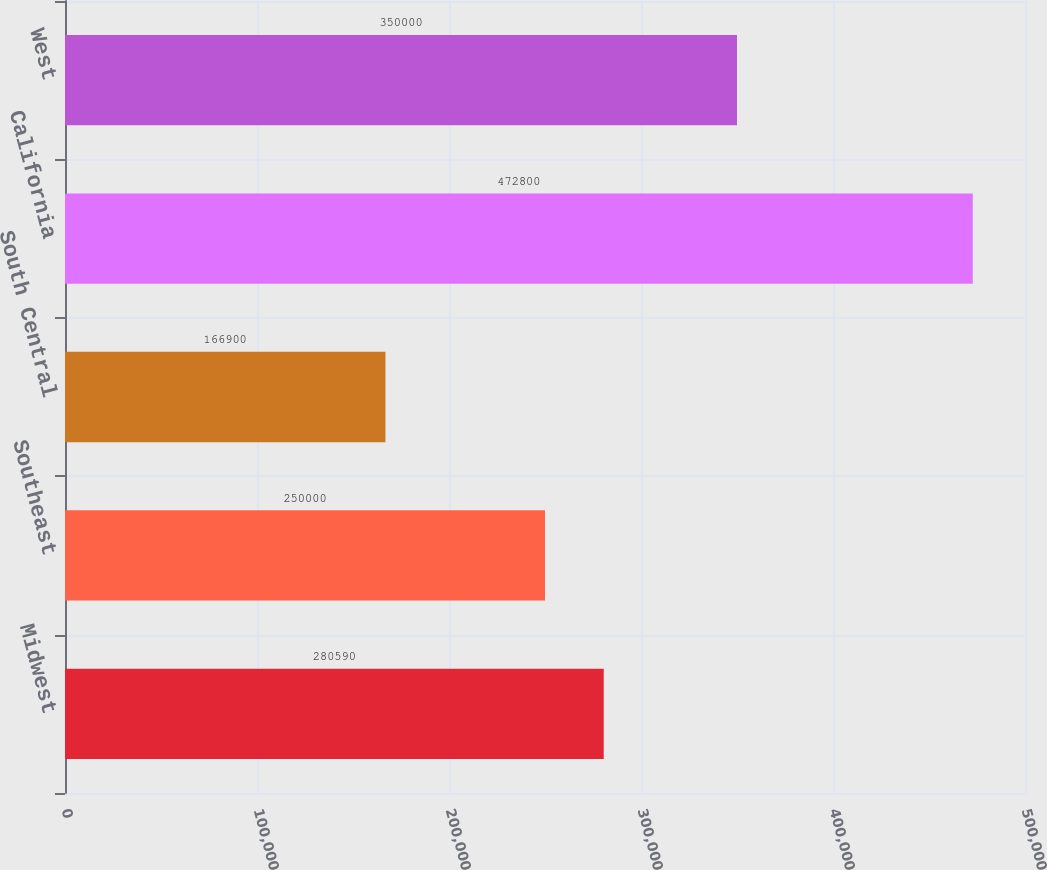<chart> <loc_0><loc_0><loc_500><loc_500><bar_chart><fcel>Midwest<fcel>Southeast<fcel>South Central<fcel>California<fcel>West<nl><fcel>280590<fcel>250000<fcel>166900<fcel>472800<fcel>350000<nl></chart> 